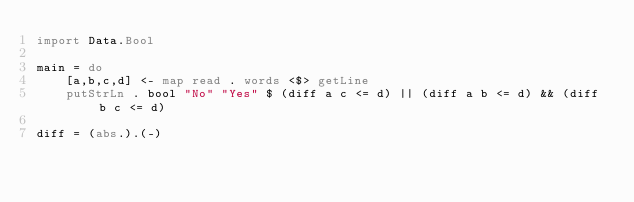Convert code to text. <code><loc_0><loc_0><loc_500><loc_500><_Haskell_>import Data.Bool

main = do
    [a,b,c,d] <- map read . words <$> getLine
    putStrLn . bool "No" "Yes" $ (diff a c <= d) || (diff a b <= d) && (diff b c <= d)

diff = (abs.).(-)
</code> 